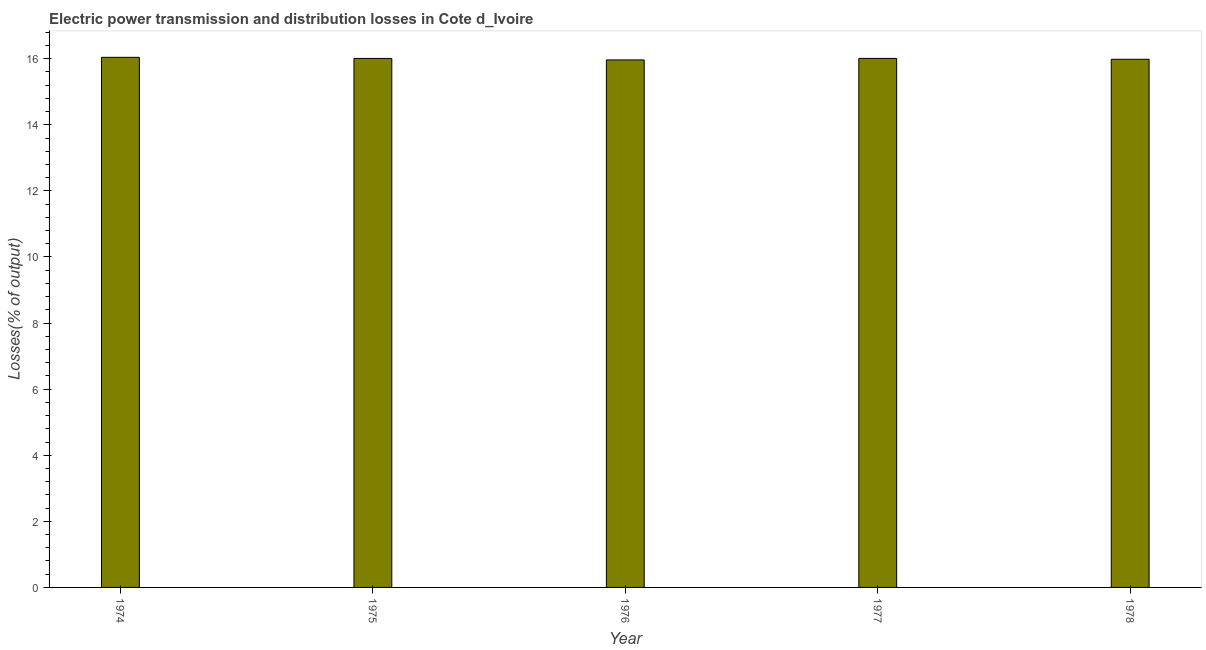Does the graph contain any zero values?
Give a very brief answer. No. Does the graph contain grids?
Offer a terse response. No. What is the title of the graph?
Offer a very short reply. Electric power transmission and distribution losses in Cote d_Ivoire. What is the label or title of the X-axis?
Ensure brevity in your answer.  Year. What is the label or title of the Y-axis?
Your answer should be compact. Losses(% of output). What is the electric power transmission and distribution losses in 1977?
Offer a very short reply. 16.01. Across all years, what is the maximum electric power transmission and distribution losses?
Make the answer very short. 16.04. Across all years, what is the minimum electric power transmission and distribution losses?
Offer a terse response. 15.96. In which year was the electric power transmission and distribution losses maximum?
Provide a succinct answer. 1974. In which year was the electric power transmission and distribution losses minimum?
Offer a very short reply. 1976. What is the sum of the electric power transmission and distribution losses?
Your response must be concise. 80.01. What is the difference between the electric power transmission and distribution losses in 1976 and 1977?
Offer a terse response. -0.05. What is the average electric power transmission and distribution losses per year?
Offer a terse response. 16. What is the median electric power transmission and distribution losses?
Your answer should be compact. 16.01. In how many years, is the electric power transmission and distribution losses greater than 2.8 %?
Give a very brief answer. 5. Do a majority of the years between 1974 and 1978 (inclusive) have electric power transmission and distribution losses greater than 2 %?
Keep it short and to the point. Yes. Is the electric power transmission and distribution losses in 1975 less than that in 1977?
Your answer should be very brief. Yes. What is the difference between the highest and the second highest electric power transmission and distribution losses?
Your response must be concise. 0.03. What is the difference between the highest and the lowest electric power transmission and distribution losses?
Offer a terse response. 0.08. How many bars are there?
Provide a short and direct response. 5. What is the difference between two consecutive major ticks on the Y-axis?
Ensure brevity in your answer.  2. Are the values on the major ticks of Y-axis written in scientific E-notation?
Keep it short and to the point. No. What is the Losses(% of output) in 1974?
Your answer should be very brief. 16.04. What is the Losses(% of output) of 1975?
Provide a short and direct response. 16.01. What is the Losses(% of output) in 1976?
Your answer should be very brief. 15.96. What is the Losses(% of output) of 1977?
Ensure brevity in your answer.  16.01. What is the Losses(% of output) of 1978?
Make the answer very short. 15.98. What is the difference between the Losses(% of output) in 1974 and 1975?
Provide a short and direct response. 0.03. What is the difference between the Losses(% of output) in 1974 and 1976?
Ensure brevity in your answer.  0.08. What is the difference between the Losses(% of output) in 1974 and 1977?
Make the answer very short. 0.03. What is the difference between the Losses(% of output) in 1974 and 1978?
Provide a short and direct response. 0.06. What is the difference between the Losses(% of output) in 1975 and 1976?
Offer a terse response. 0.04. What is the difference between the Losses(% of output) in 1975 and 1977?
Give a very brief answer. -0. What is the difference between the Losses(% of output) in 1975 and 1978?
Make the answer very short. 0.03. What is the difference between the Losses(% of output) in 1976 and 1977?
Keep it short and to the point. -0.05. What is the difference between the Losses(% of output) in 1976 and 1978?
Offer a very short reply. -0.02. What is the difference between the Losses(% of output) in 1977 and 1978?
Offer a terse response. 0.03. What is the ratio of the Losses(% of output) in 1974 to that in 1975?
Make the answer very short. 1. What is the ratio of the Losses(% of output) in 1974 to that in 1978?
Provide a succinct answer. 1. What is the ratio of the Losses(% of output) in 1975 to that in 1976?
Make the answer very short. 1. What is the ratio of the Losses(% of output) in 1975 to that in 1977?
Provide a succinct answer. 1. What is the ratio of the Losses(% of output) in 1975 to that in 1978?
Your response must be concise. 1. What is the ratio of the Losses(% of output) in 1976 to that in 1977?
Give a very brief answer. 1. 